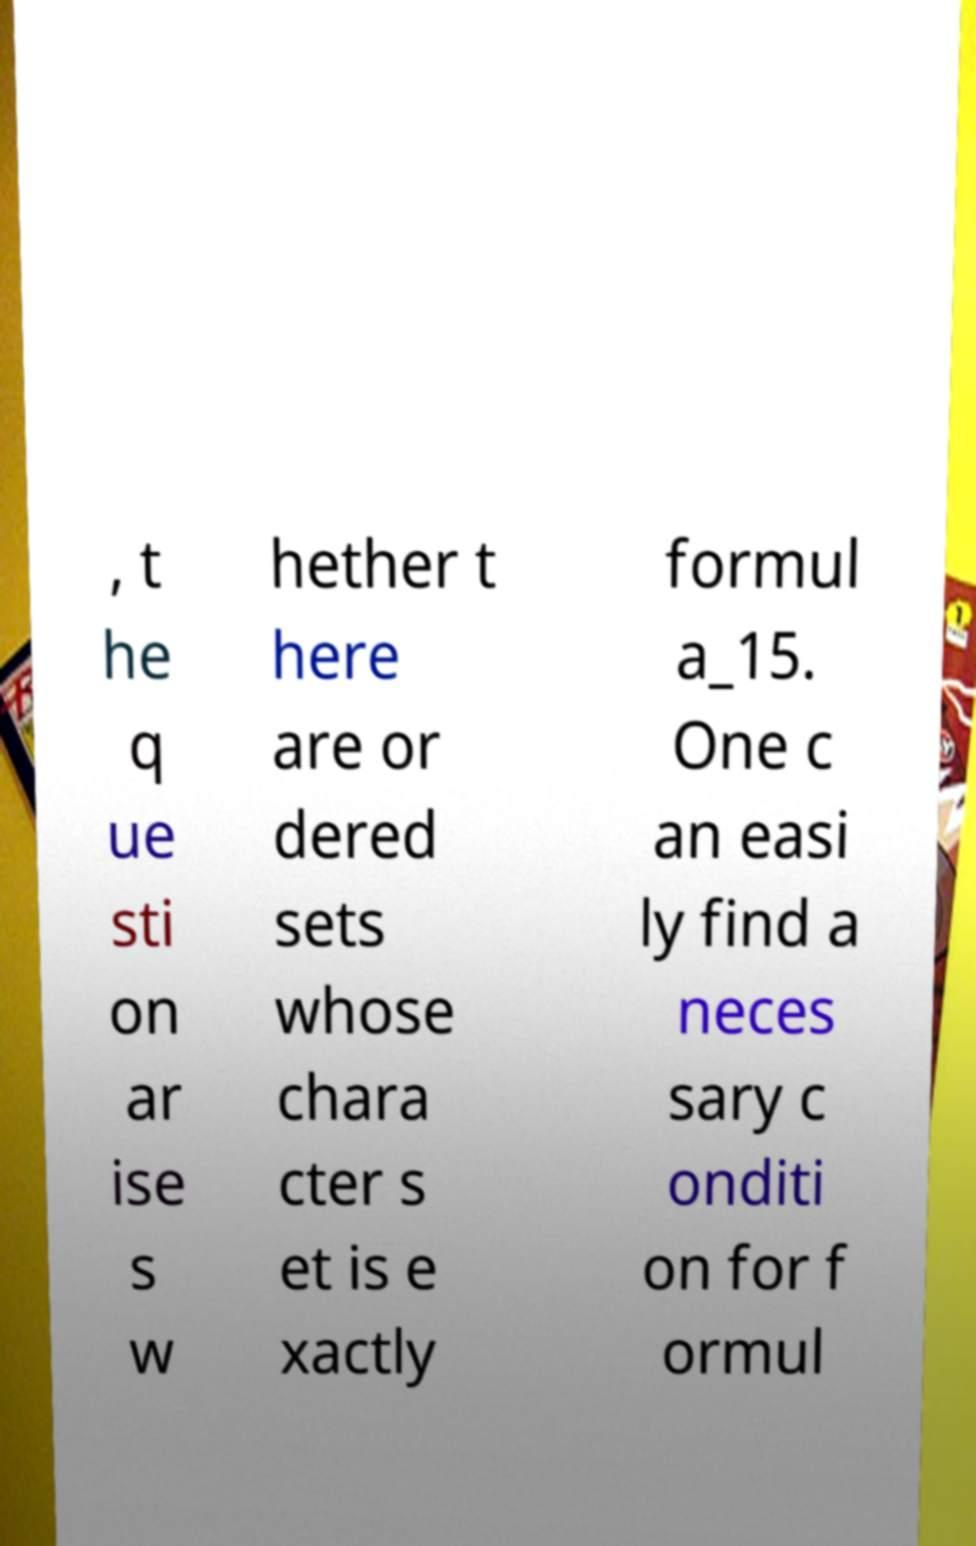Please identify and transcribe the text found in this image. , t he q ue sti on ar ise s w hether t here are or dered sets whose chara cter s et is e xactly formul a_15. One c an easi ly find a neces sary c onditi on for f ormul 